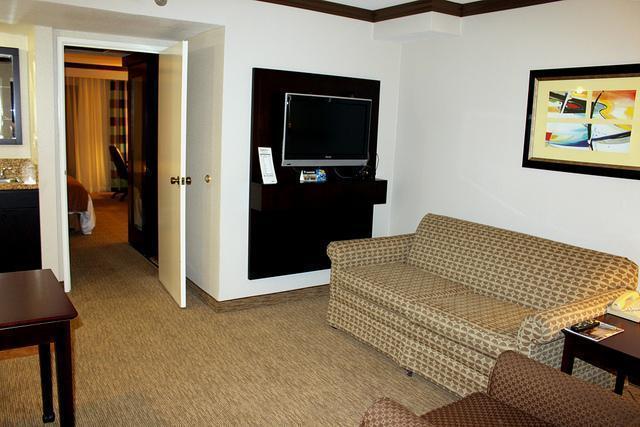Which country is famous for paintings?
Choose the correct response, then elucidate: 'Answer: answer
Rationale: rationale.'
Options: France, rome italy, poland, canada. Answer: rome italy.
Rationale: Many countries have famous painters 